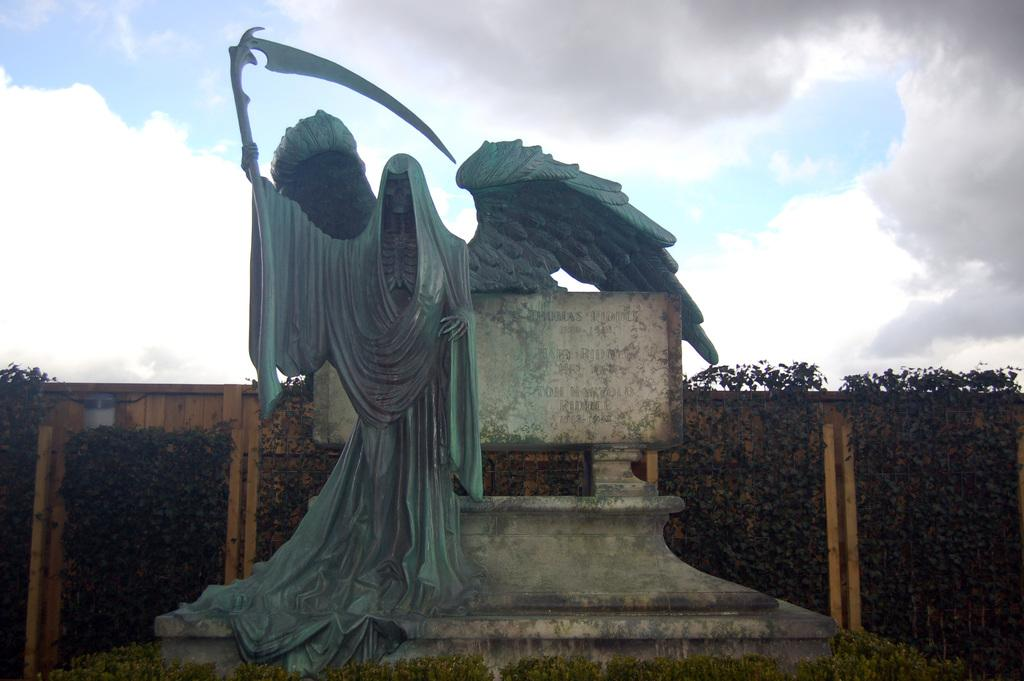What is the main subject in the center of the image? There is a statue in the center of the image. What type of vegetation is present at the bottom of the image? There is grass at the bottom of the image. What can be seen in the background of the image? There is a wall and a hedge in the background of the image. What is visible at the top of the image? The sky is visible at the top of the image. What is the taste of the alley in the image? There is no alley present in the image, and therefore it cannot be tasted. 